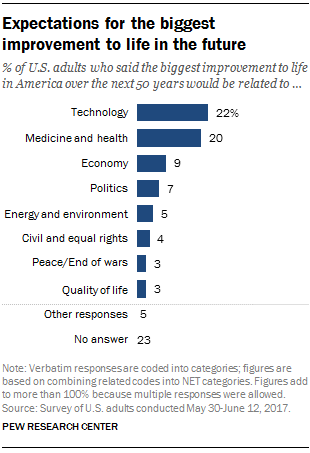Highlight a few significant elements in this photo. There is one category in the chart. The percentage representation of 'economy' and 'politics' on the chart is 16% and 14%, respectively. 